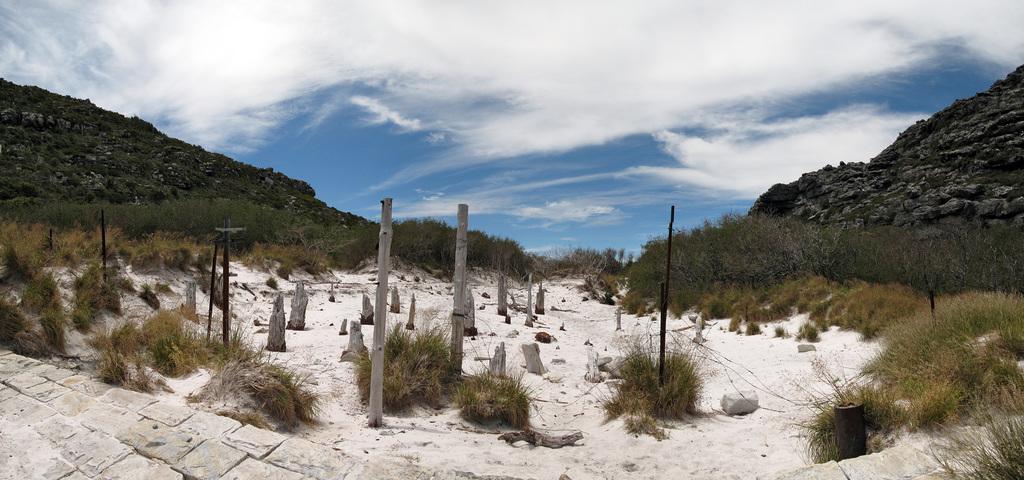Describe this image in one or two sentences. In the picture I can see poles, the grass, plants, trees and mountains. In the background I can see the sky. 